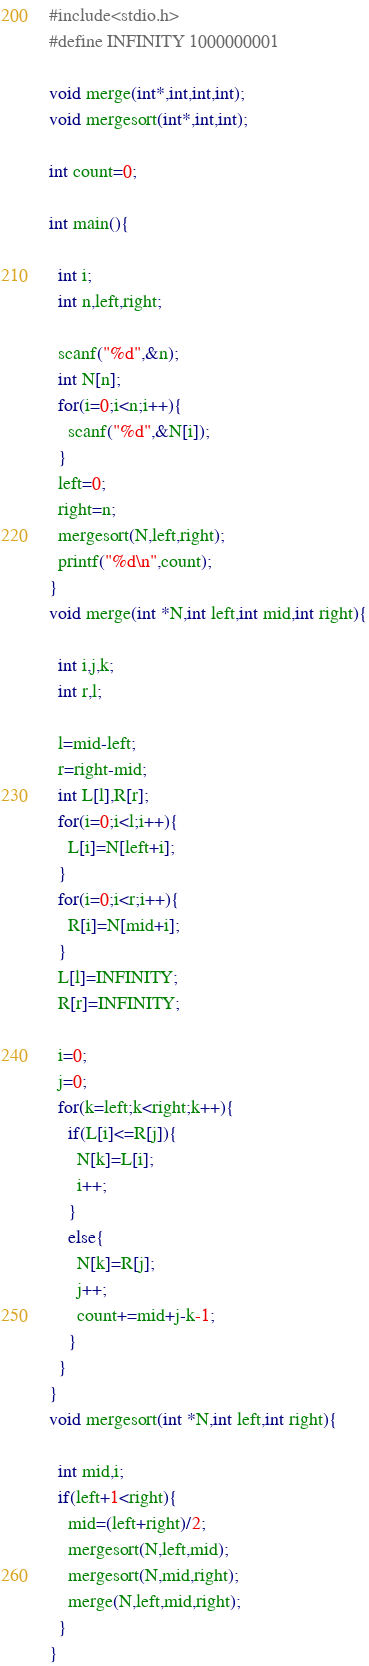Convert code to text. <code><loc_0><loc_0><loc_500><loc_500><_C_>#include<stdio.h>
#define INFINITY 1000000001

void merge(int*,int,int,int);
void mergesort(int*,int,int);

int count=0;

int main(){

  int i;
  int n,left,right;

  scanf("%d",&n);
  int N[n];
  for(i=0;i<n;i++){
    scanf("%d",&N[i]);
  }
  left=0;
  right=n;
  mergesort(N,left,right);
  printf("%d\n",count);
}
void merge(int *N,int left,int mid,int right){

  int i,j,k;
  int r,l;
    
  l=mid-left;
  r=right-mid;
  int L[l],R[r];
  for(i=0;i<l;i++){
    L[i]=N[left+i];
  }
  for(i=0;i<r;i++){
    R[i]=N[mid+i];
  }
  L[l]=INFINITY;
  R[r]=INFINITY;
  
  i=0;
  j=0;
  for(k=left;k<right;k++){
    if(L[i]<=R[j]){
      N[k]=L[i];
      i++;
    }
    else{
      N[k]=R[j];
      j++;
      count+=mid+j-k-1;
    }
  }
}
void mergesort(int *N,int left,int right){

  int mid,i;
  if(left+1<right){
    mid=(left+right)/2;
    mergesort(N,left,mid);
    mergesort(N,mid,right);
    merge(N,left,mid,right);
  }
}

</code> 